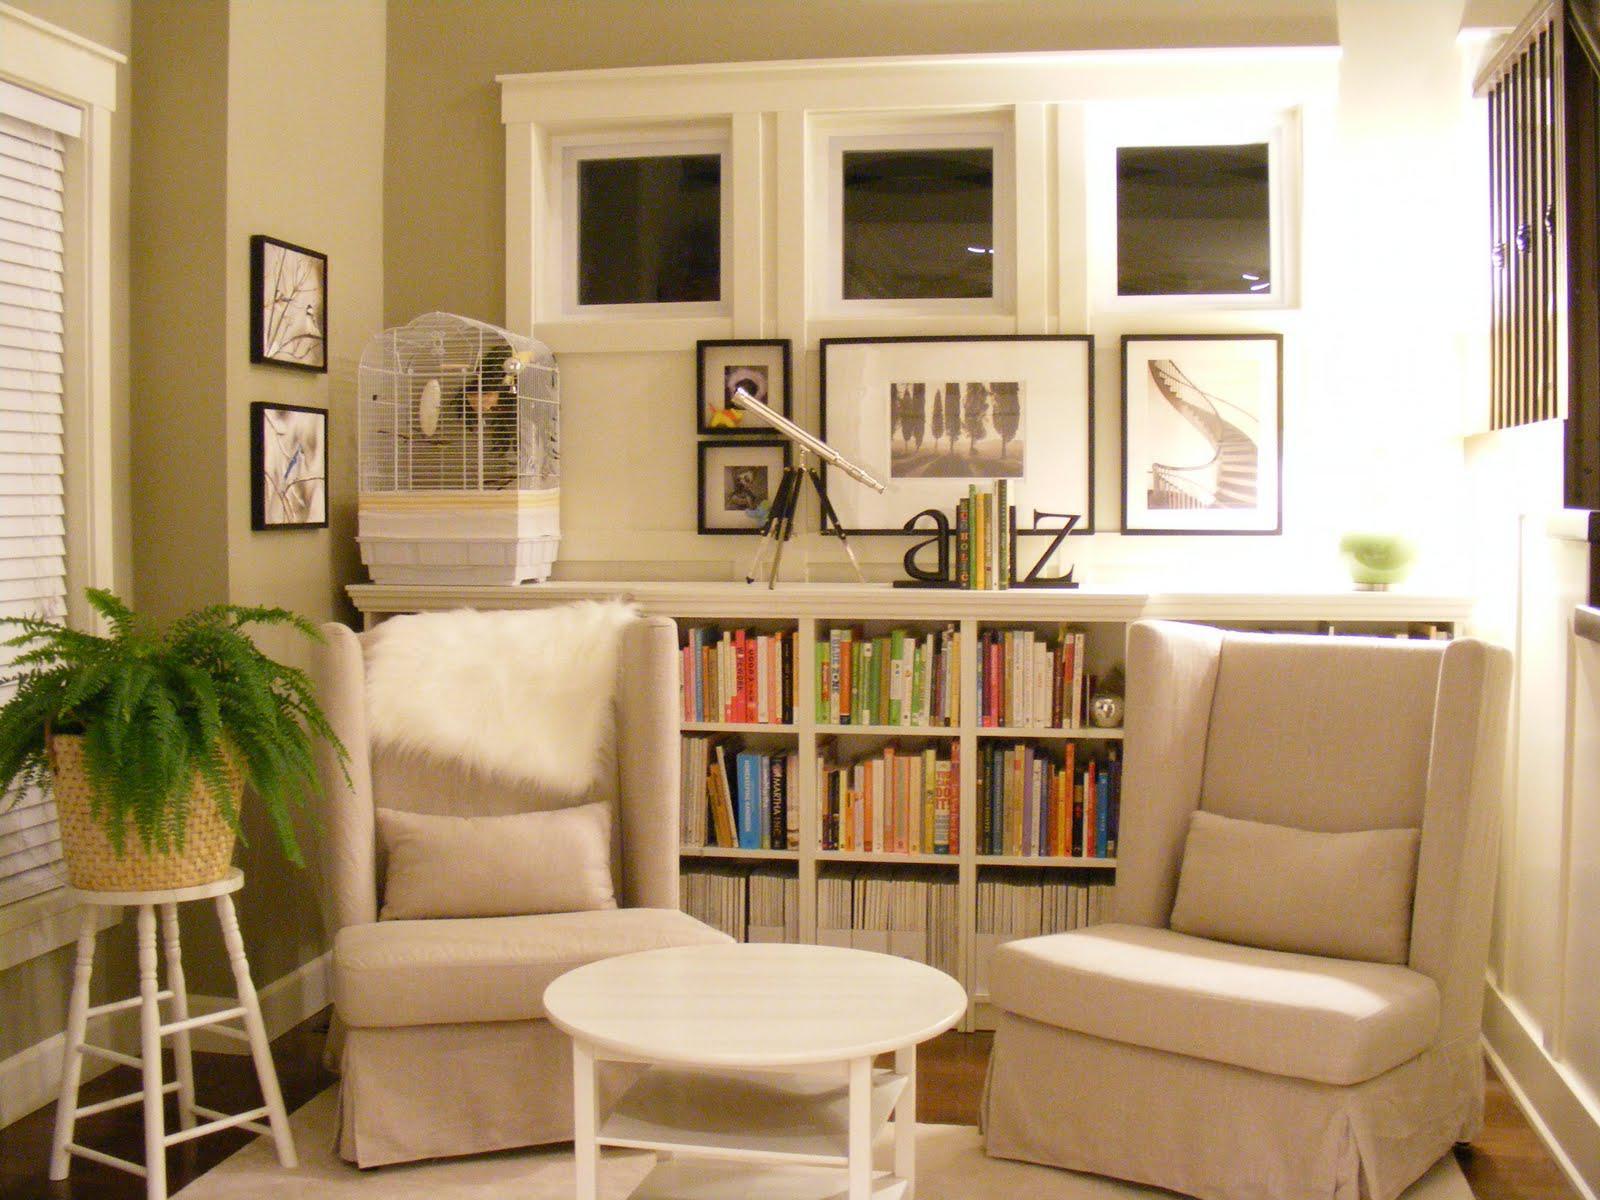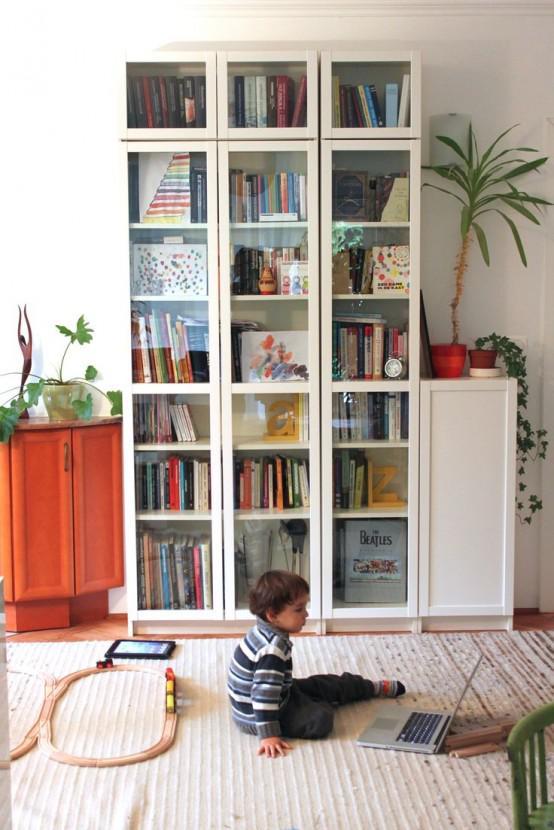The first image is the image on the left, the second image is the image on the right. For the images shown, is this caption "The bookshelves in both pictures are facing the left side of the picture." true? Answer yes or no. No. The first image is the image on the left, the second image is the image on the right. Given the left and right images, does the statement "a bookshelf is behind a small white table" hold true? Answer yes or no. Yes. 